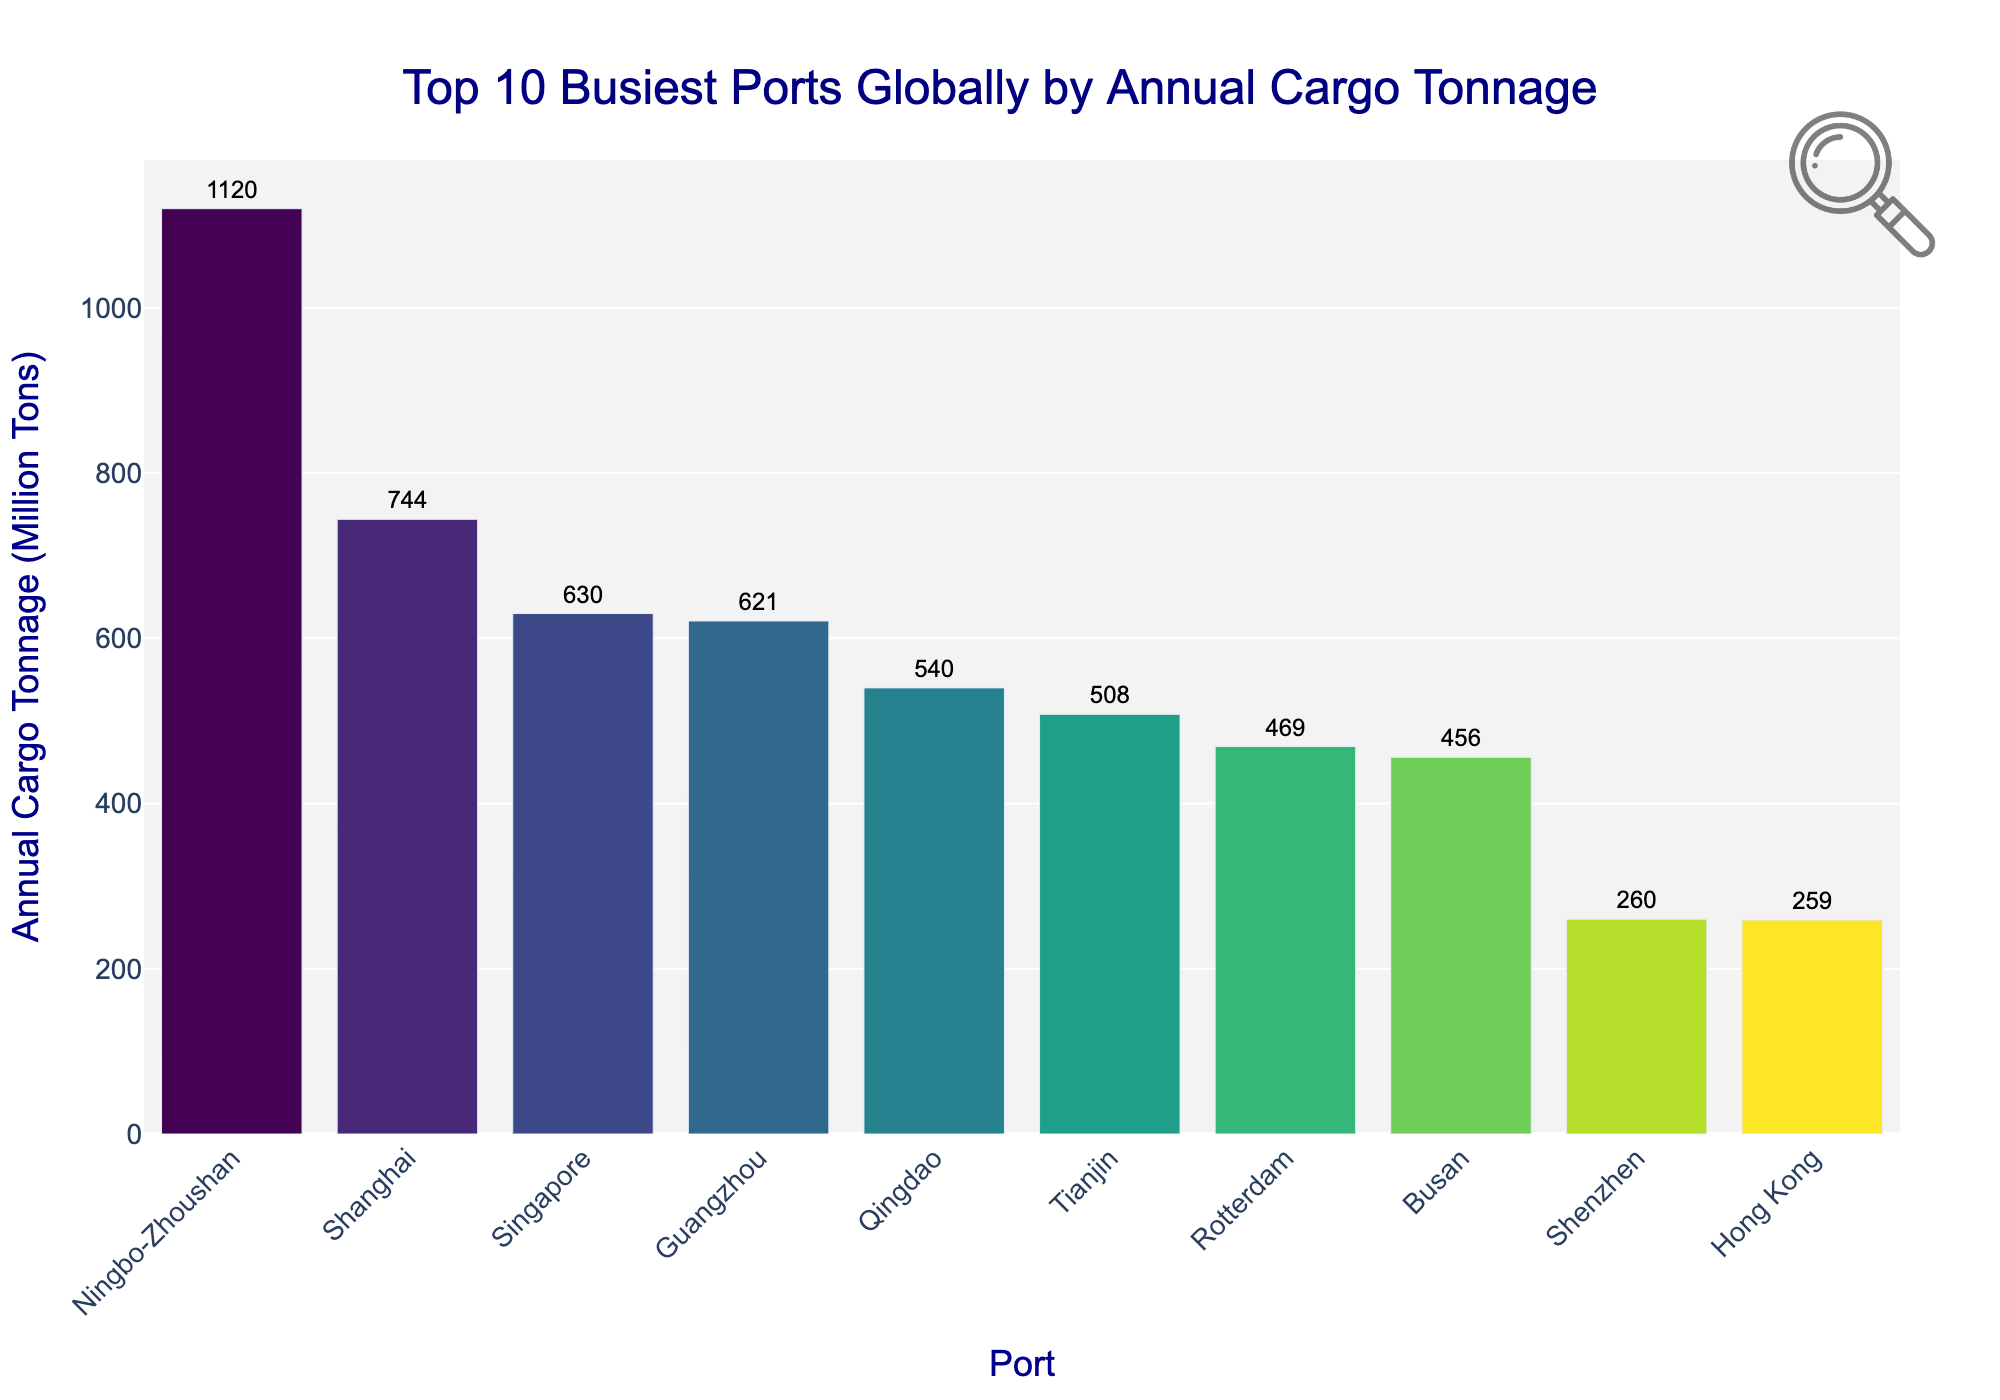Which port has the highest annual cargo tonnage? The bar corresponding to the Ningbo-Zhoushan port is the tallest in the chart. Looking closely at the values on top of each bar, the Ningbo-Zhoushan port has 1120 million tons.
Answer: Ningbo-Zhoushan Which port ranks 3rd in terms of annual cargo tonnage? The labels showing the names of the ports are clearly aligned with the bars. The third tallest bar has the label "Shanghai" and the value shows 744 million tons.
Answer: Shanghai What is the difference in annual cargo tonnage between the Guangzhou and Busan ports? Identify the bars for Guangzhou and Busan and read their values: Guangzhou has 621 million tons, Busan has 456 million tons. The difference is 621 - 456.
Answer: 165 million tons How many ports have an annual cargo tonnage greater than 500 million tons? From the figure, count the bars with values over 500 million tons: Ports are Ningbo-Zhoushan, Shanghai, Singapore, Guangzhou, Qingdao, and Tianjin. There are 6 such ports.
Answer: 6 Which port has the lowest annual cargo tonnage among the top 10? Compare the heights of all bars and identify the shortest one. The shortest bar corresponds to Hong Kong with 259 million tons.
Answer: Hong Kong What is the combined annual cargo tonnage of the top 2 ports? The bars for Ningbo-Zhoushan and Shanghai display values of 1120 and 744 million tons respectively. Adding these two values: 1120 + 744.
Answer: 1864 million tons Is the annual cargo tonnage of Qingdao more than that of Tianjin? Examine the respective bars. Qingdao has 540 million tons, whereas Tianjin has 508 million tons.
Answer: Yes What is the average annual cargo tonnage of the ports listed? Add the tonnage values of all ports: (744 + 630 + 1120 + 621 + 540 + 469 + 508 + 456 + 259 + 260) and divide by the number of ports (10). (5607 / 10).
Answer: 560.7 million tons How many ports have annual cargo tonnage values between 400 and 600 million tons? Identify bars within the range of 400 to 600 million tons. These ports are Guangzhou, Qingdao, Tianjin, and Busan, making it 4 ports.
Answer: 4 